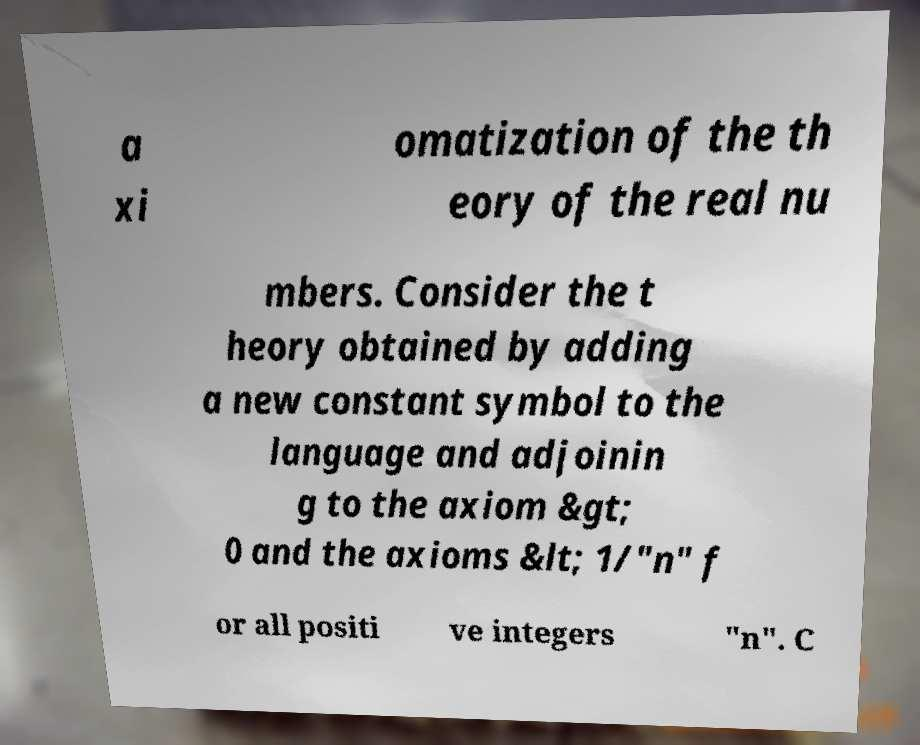Can you accurately transcribe the text from the provided image for me? a xi omatization of the th eory of the real nu mbers. Consider the t heory obtained by adding a new constant symbol to the language and adjoinin g to the axiom &gt; 0 and the axioms &lt; 1/"n" f or all positi ve integers "n". C 